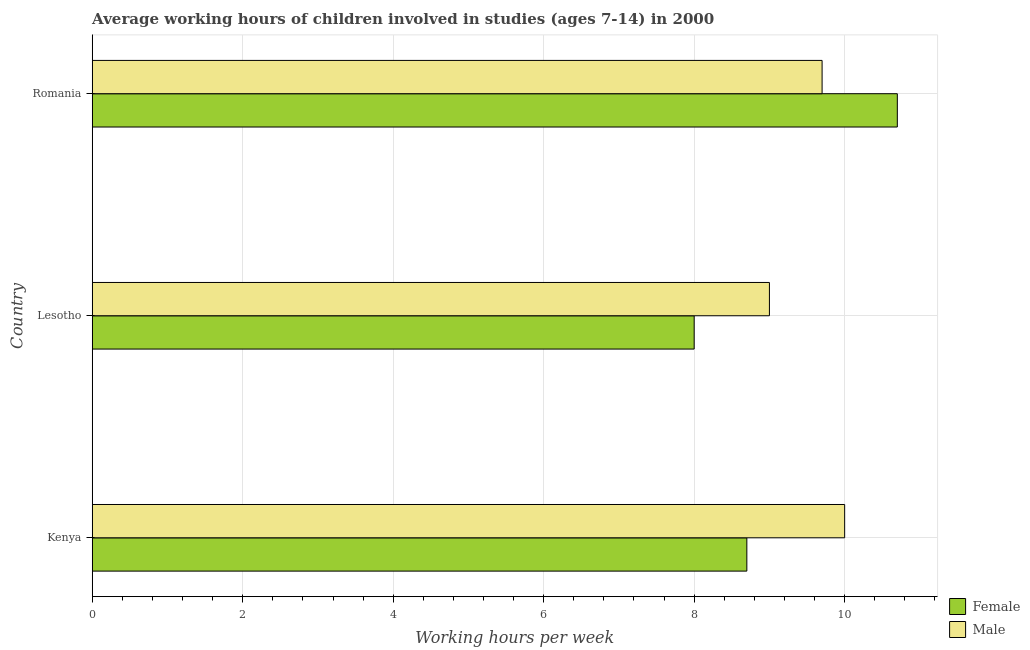How many different coloured bars are there?
Your answer should be very brief. 2. How many groups of bars are there?
Provide a succinct answer. 3. Are the number of bars on each tick of the Y-axis equal?
Your response must be concise. Yes. How many bars are there on the 2nd tick from the top?
Offer a very short reply. 2. How many bars are there on the 3rd tick from the bottom?
Ensure brevity in your answer.  2. What is the label of the 2nd group of bars from the top?
Your answer should be compact. Lesotho. In how many cases, is the number of bars for a given country not equal to the number of legend labels?
Ensure brevity in your answer.  0. Across all countries, what is the minimum average working hour of male children?
Make the answer very short. 9. In which country was the average working hour of male children maximum?
Ensure brevity in your answer.  Kenya. In which country was the average working hour of female children minimum?
Offer a terse response. Lesotho. What is the total average working hour of male children in the graph?
Your response must be concise. 28.7. What is the difference between the average working hour of female children in Lesotho and that in Romania?
Your answer should be compact. -2.7. What is the difference between the average working hour of female children in Kenya and the average working hour of male children in Lesotho?
Your response must be concise. -0.3. What is the average average working hour of female children per country?
Ensure brevity in your answer.  9.13. What is the difference between the average working hour of male children and average working hour of female children in Romania?
Provide a succinct answer. -1. In how many countries, is the average working hour of female children greater than 6 hours?
Offer a very short reply. 3. What is the ratio of the average working hour of female children in Kenya to that in Romania?
Provide a succinct answer. 0.81. Is the difference between the average working hour of female children in Lesotho and Romania greater than the difference between the average working hour of male children in Lesotho and Romania?
Make the answer very short. No. What is the difference between the highest and the second highest average working hour of female children?
Keep it short and to the point. 2. What is the difference between the highest and the lowest average working hour of female children?
Provide a short and direct response. 2.7. What does the 1st bar from the top in Lesotho represents?
Give a very brief answer. Male. What does the 2nd bar from the bottom in Romania represents?
Offer a very short reply. Male. How many bars are there?
Make the answer very short. 6. Are all the bars in the graph horizontal?
Provide a succinct answer. Yes. How many countries are there in the graph?
Your response must be concise. 3. Are the values on the major ticks of X-axis written in scientific E-notation?
Your answer should be compact. No. Does the graph contain grids?
Ensure brevity in your answer.  Yes. Where does the legend appear in the graph?
Provide a succinct answer. Bottom right. What is the title of the graph?
Your answer should be very brief. Average working hours of children involved in studies (ages 7-14) in 2000. What is the label or title of the X-axis?
Your response must be concise. Working hours per week. What is the label or title of the Y-axis?
Your answer should be very brief. Country. What is the Working hours per week of Female in Kenya?
Your response must be concise. 8.7. What is the Working hours per week of Male in Lesotho?
Make the answer very short. 9. What is the Working hours per week in Female in Romania?
Offer a very short reply. 10.7. Across all countries, what is the maximum Working hours per week of Female?
Offer a very short reply. 10.7. Across all countries, what is the minimum Working hours per week of Female?
Offer a terse response. 8. What is the total Working hours per week of Female in the graph?
Keep it short and to the point. 27.4. What is the total Working hours per week in Male in the graph?
Offer a very short reply. 28.7. What is the difference between the Working hours per week of Male in Kenya and that in Lesotho?
Give a very brief answer. 1. What is the difference between the Working hours per week of Female in Kenya and that in Romania?
Offer a terse response. -2. What is the difference between the Working hours per week in Male in Kenya and that in Romania?
Your answer should be compact. 0.3. What is the difference between the Working hours per week of Female in Lesotho and that in Romania?
Your answer should be compact. -2.7. What is the difference between the Working hours per week in Male in Lesotho and that in Romania?
Offer a terse response. -0.7. What is the difference between the Working hours per week in Female in Lesotho and the Working hours per week in Male in Romania?
Provide a succinct answer. -1.7. What is the average Working hours per week of Female per country?
Offer a very short reply. 9.13. What is the average Working hours per week in Male per country?
Your answer should be compact. 9.57. What is the difference between the Working hours per week in Female and Working hours per week in Male in Lesotho?
Your answer should be very brief. -1. What is the difference between the Working hours per week of Female and Working hours per week of Male in Romania?
Your answer should be very brief. 1. What is the ratio of the Working hours per week of Female in Kenya to that in Lesotho?
Ensure brevity in your answer.  1.09. What is the ratio of the Working hours per week of Female in Kenya to that in Romania?
Offer a very short reply. 0.81. What is the ratio of the Working hours per week in Male in Kenya to that in Romania?
Provide a short and direct response. 1.03. What is the ratio of the Working hours per week of Female in Lesotho to that in Romania?
Provide a short and direct response. 0.75. What is the ratio of the Working hours per week of Male in Lesotho to that in Romania?
Your answer should be very brief. 0.93. What is the difference between the highest and the lowest Working hours per week in Female?
Provide a short and direct response. 2.7. 